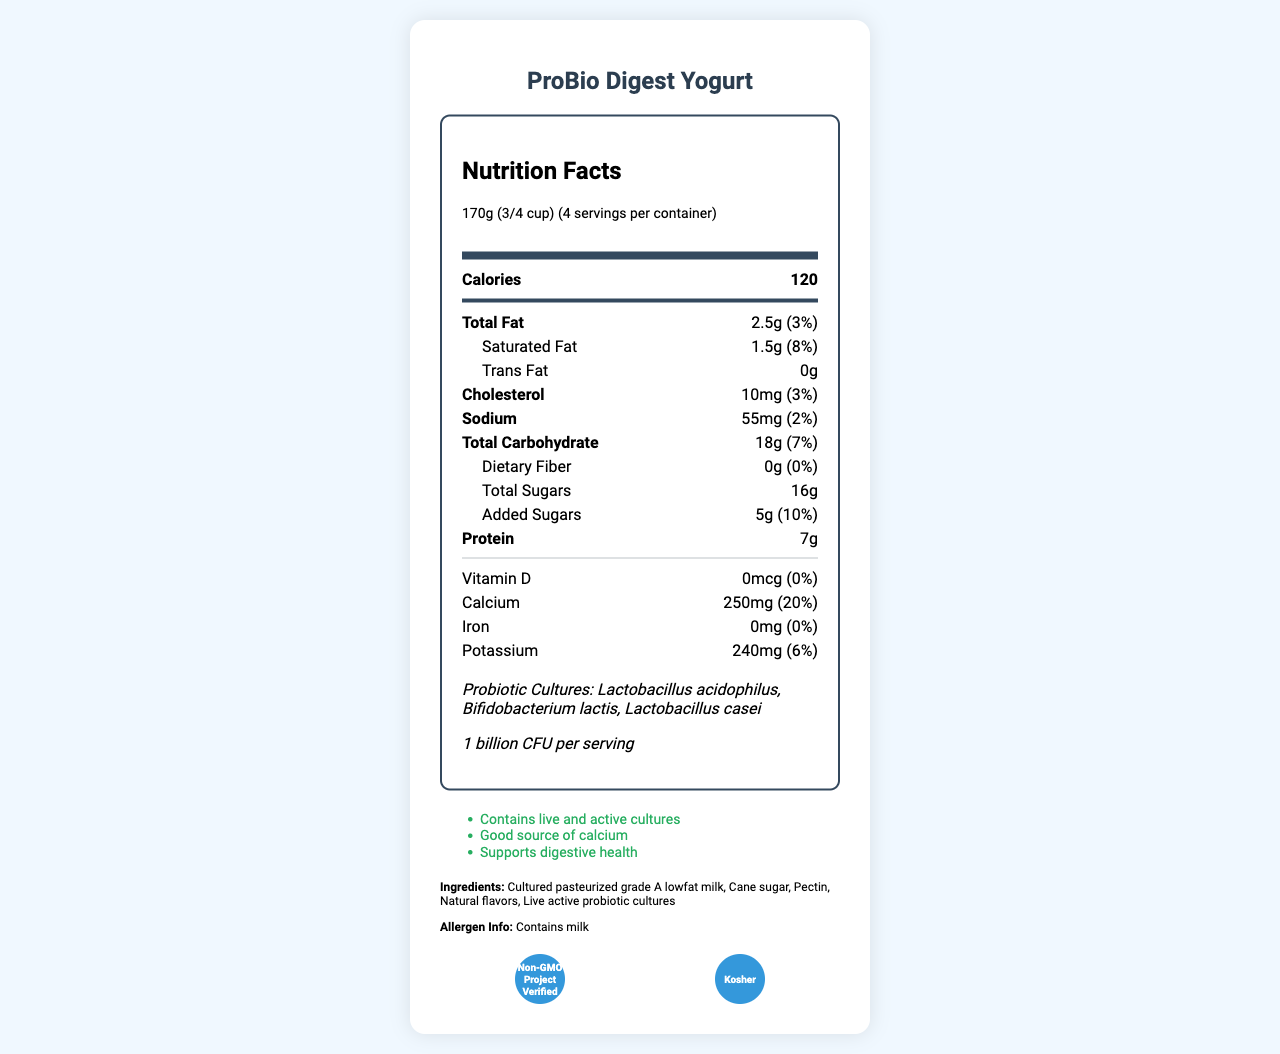what is the serving size of "ProBio Digest Yogurt"? The serving size is mentioned as 170g (3/4 cup) at the top under the "Nutrition Facts" section.
Answer: 170g (3/4 cup) how many servings are there per container? "4 servings per container" is written next to the serving size information at the top of the document.
Answer: 4 how much calcium is in one serving? The amount of calcium per serving is listed as 250mg, which is 20% of the daily value.
Answer: 250mg what are the main benefits claimed for this yogurt? These health claims are explicitly listed under the "health-claims" section.
Answer: Contains live and active cultures, Good source of calcium, Supports digestive health what allergens are present in this product? The allergen information states that the product "Contains milk".
Answer: Milk which of the following probiotic strains are present in the yogurt? A. Lactobacillus acidophilus B. Bifidobacterium lactis C. Lactobacillus casei D. All of the above All listed strains (Lactobacillus acidophilus, Bifidobacterium lactis, and Lactobacillus casei) are mentioned under the probiotic cultures information.
Answer: D. All of the above how many grams of saturated fat does a serving of this yogurt contain? A. 0.5g B. 1.5g C. 2.5g D. 3g The document shows that the saturated fat content per serving is 1.5g.
Answer: B. 1.5g is this yogurt certified Non-GMO? The yogurt has the "Non-GMO Project Verified" certification, as noted in the certifications section.
Answer: Yes does this product contain any iron? The document states that the iron content is 0mg which is 0% of the daily value.
Answer: No describe the main nutritional and health features of "ProBio Digest Yogurt". The document provides comprehensive details of the yogurt's nutritional content per serving, highlighting its low fat, high calcium, and probiotic cultures which are beneficial for digestive health.
Answer: The "ProBio Digest Yogurt" offers various health benefits, emphasizing its live and active cultures which support digestive health. Each serving of 170g contains 120 calories, with 2.5g of total fat, 7g of protein, and is a good source of calcium with 250mg per serving (20% of daily value). It also has 1 billion CFU of probiotic cultures from strains such as Lactobacillus acidophilus, Bifidobacterium lactis, and Lactobacillus casei. what is the percentage of daily value for vitamin D in this yogurt? The vitamin D content is listed as 0mcg, which is 0% of the daily value.
Answer: 0% who is the manufacturer of "ProBio Digest Yogurt"? The manufacturer's name is provided at the bottom under the product's information.
Answer: HealthyGut Foods, Inc. how many calories are in one serving of this yogurt? The calorie information is displayed prominently at the top of the nutrition facts section.
Answer: 120 what is the consumer hotline number for this product? The consumer hotline number is listed at the bottom of the document under the product’s information.
Answer: 1-800-555-PROB is this yogurt Kosher certified? The document states that the yogurt is Kosher certified, as indicated in the certifications section.
Answer: Yes what are the natural flavors added to this yogurt? The document mentions "natural flavors" as an ingredient but does not specify what those natural flavors are.
Answer: Cannot be determined 